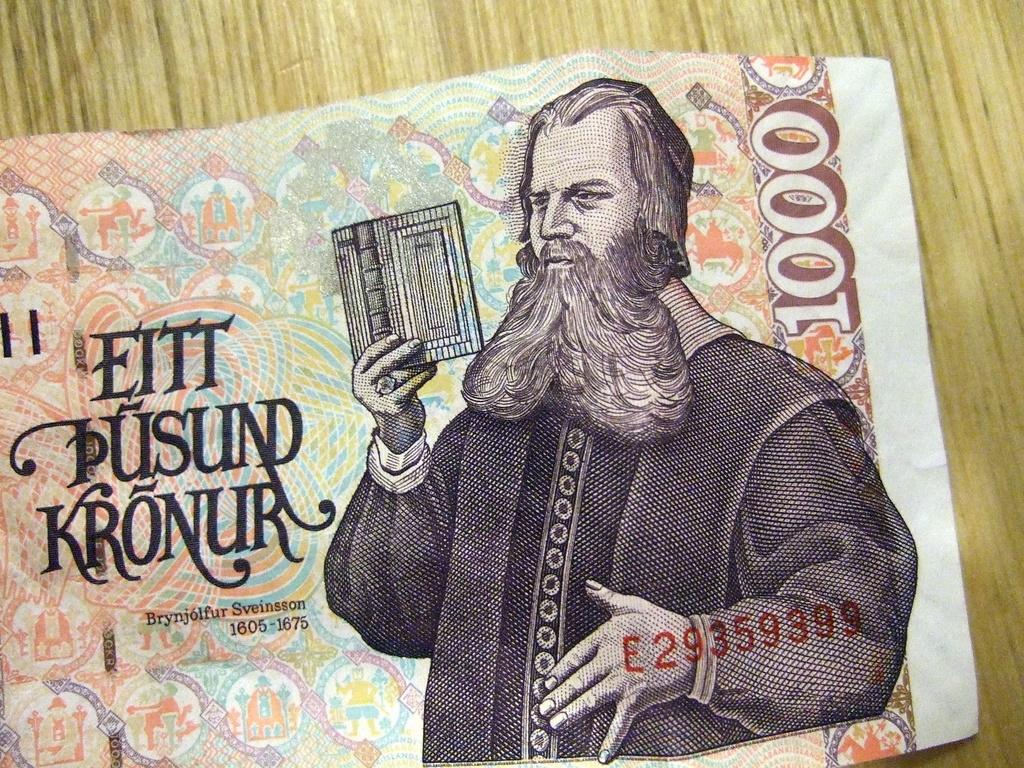What type of currency is depicted in the image? There is a kronur banknote in the image. What other object can be seen in the image besides the banknote? There is a wooden object in the image. What type of elbow is featured on the wooden object in the image? There is no elbow present on the wooden object in the image. 